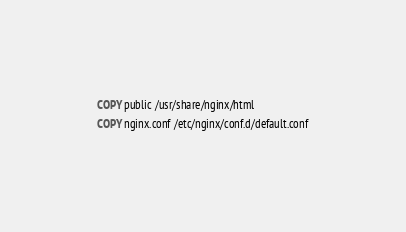Convert code to text. <code><loc_0><loc_0><loc_500><loc_500><_Dockerfile_>COPY public /usr/share/nginx/html
COPY nginx.conf /etc/nginx/conf.d/default.conf</code> 